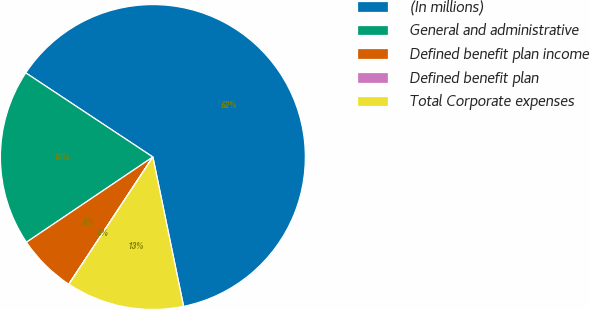Convert chart. <chart><loc_0><loc_0><loc_500><loc_500><pie_chart><fcel>(In millions)<fcel>General and administrative<fcel>Defined benefit plan income<fcel>Defined benefit plan<fcel>Total Corporate expenses<nl><fcel>62.47%<fcel>18.75%<fcel>6.26%<fcel>0.02%<fcel>12.51%<nl></chart> 